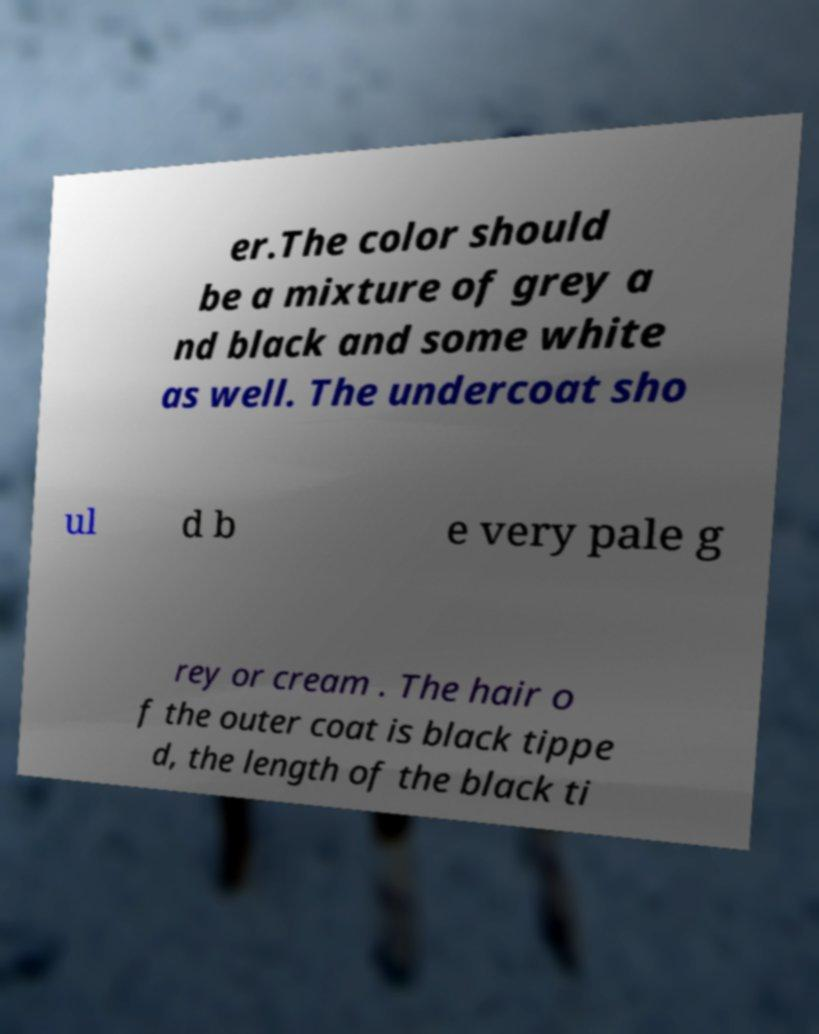Could you extract and type out the text from this image? er.The color should be a mixture of grey a nd black and some white as well. The undercoat sho ul d b e very pale g rey or cream . The hair o f the outer coat is black tippe d, the length of the black ti 